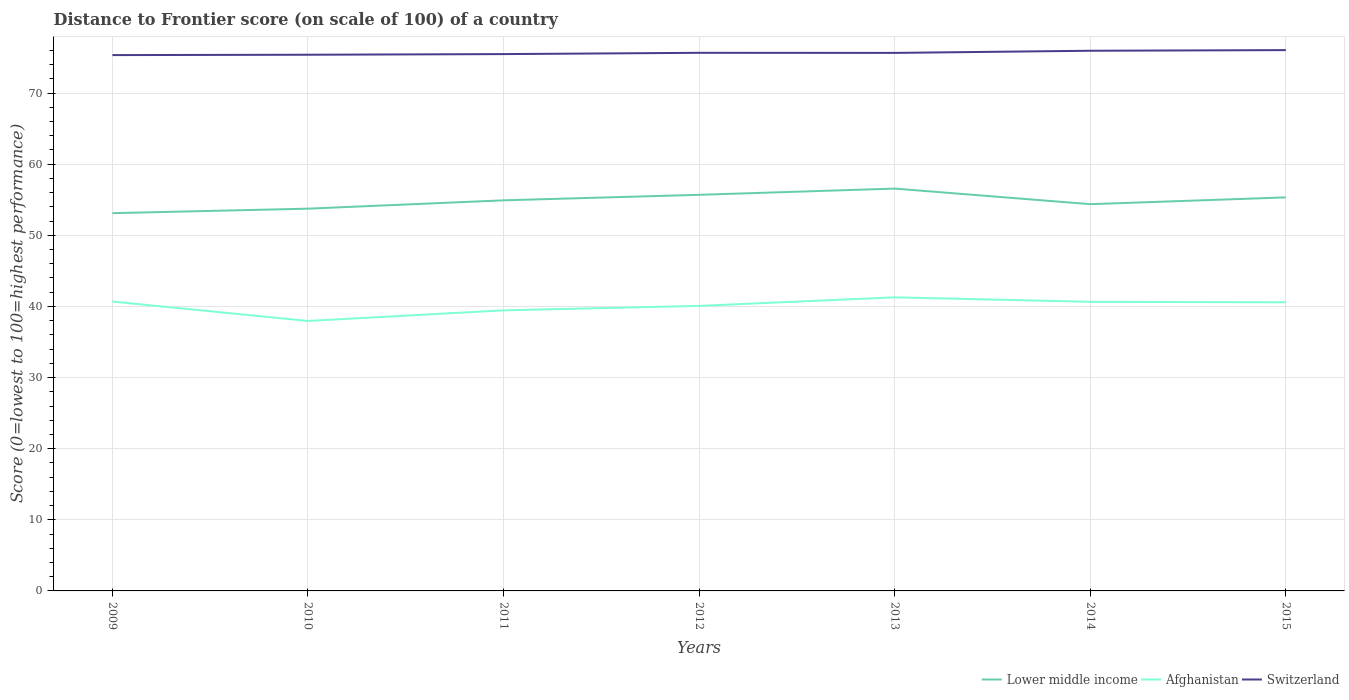Does the line corresponding to Switzerland intersect with the line corresponding to Afghanistan?
Ensure brevity in your answer.  No. Across all years, what is the maximum distance to frontier score of in Switzerland?
Offer a very short reply. 75.34. In which year was the distance to frontier score of in Lower middle income maximum?
Offer a terse response. 2009. What is the total distance to frontier score of in Lower middle income in the graph?
Your response must be concise. -0.87. What is the difference between the highest and the second highest distance to frontier score of in Switzerland?
Your response must be concise. 0.7. What is the difference between the highest and the lowest distance to frontier score of in Switzerland?
Your answer should be compact. 4. How many lines are there?
Ensure brevity in your answer.  3. How many years are there in the graph?
Make the answer very short. 7. What is the difference between two consecutive major ticks on the Y-axis?
Your answer should be very brief. 10. Does the graph contain any zero values?
Your answer should be very brief. No. How are the legend labels stacked?
Offer a terse response. Horizontal. What is the title of the graph?
Your answer should be very brief. Distance to Frontier score (on scale of 100) of a country. What is the label or title of the Y-axis?
Offer a terse response. Score (0=lowest to 100=highest performance). What is the Score (0=lowest to 100=highest performance) of Lower middle income in 2009?
Offer a very short reply. 53.12. What is the Score (0=lowest to 100=highest performance) of Afghanistan in 2009?
Provide a succinct answer. 40.69. What is the Score (0=lowest to 100=highest performance) in Switzerland in 2009?
Your answer should be very brief. 75.34. What is the Score (0=lowest to 100=highest performance) of Lower middle income in 2010?
Your answer should be very brief. 53.75. What is the Score (0=lowest to 100=highest performance) in Afghanistan in 2010?
Make the answer very short. 37.96. What is the Score (0=lowest to 100=highest performance) of Switzerland in 2010?
Provide a short and direct response. 75.39. What is the Score (0=lowest to 100=highest performance) in Lower middle income in 2011?
Keep it short and to the point. 54.92. What is the Score (0=lowest to 100=highest performance) in Afghanistan in 2011?
Offer a very short reply. 39.45. What is the Score (0=lowest to 100=highest performance) in Switzerland in 2011?
Ensure brevity in your answer.  75.48. What is the Score (0=lowest to 100=highest performance) in Lower middle income in 2012?
Your response must be concise. 55.7. What is the Score (0=lowest to 100=highest performance) in Afghanistan in 2012?
Your answer should be very brief. 40.08. What is the Score (0=lowest to 100=highest performance) of Switzerland in 2012?
Offer a terse response. 75.66. What is the Score (0=lowest to 100=highest performance) of Lower middle income in 2013?
Keep it short and to the point. 56.57. What is the Score (0=lowest to 100=highest performance) of Afghanistan in 2013?
Provide a short and direct response. 41.28. What is the Score (0=lowest to 100=highest performance) of Switzerland in 2013?
Your answer should be very brief. 75.65. What is the Score (0=lowest to 100=highest performance) in Lower middle income in 2014?
Your answer should be very brief. 54.38. What is the Score (0=lowest to 100=highest performance) in Afghanistan in 2014?
Make the answer very short. 40.65. What is the Score (0=lowest to 100=highest performance) of Switzerland in 2014?
Keep it short and to the point. 75.95. What is the Score (0=lowest to 100=highest performance) of Lower middle income in 2015?
Ensure brevity in your answer.  55.33. What is the Score (0=lowest to 100=highest performance) in Afghanistan in 2015?
Your response must be concise. 40.58. What is the Score (0=lowest to 100=highest performance) of Switzerland in 2015?
Your answer should be compact. 76.04. Across all years, what is the maximum Score (0=lowest to 100=highest performance) in Lower middle income?
Your answer should be compact. 56.57. Across all years, what is the maximum Score (0=lowest to 100=highest performance) of Afghanistan?
Keep it short and to the point. 41.28. Across all years, what is the maximum Score (0=lowest to 100=highest performance) in Switzerland?
Ensure brevity in your answer.  76.04. Across all years, what is the minimum Score (0=lowest to 100=highest performance) in Lower middle income?
Your answer should be compact. 53.12. Across all years, what is the minimum Score (0=lowest to 100=highest performance) in Afghanistan?
Make the answer very short. 37.96. Across all years, what is the minimum Score (0=lowest to 100=highest performance) of Switzerland?
Your response must be concise. 75.34. What is the total Score (0=lowest to 100=highest performance) in Lower middle income in the graph?
Give a very brief answer. 383.76. What is the total Score (0=lowest to 100=highest performance) of Afghanistan in the graph?
Give a very brief answer. 280.69. What is the total Score (0=lowest to 100=highest performance) of Switzerland in the graph?
Your answer should be very brief. 529.51. What is the difference between the Score (0=lowest to 100=highest performance) in Lower middle income in 2009 and that in 2010?
Ensure brevity in your answer.  -0.63. What is the difference between the Score (0=lowest to 100=highest performance) in Afghanistan in 2009 and that in 2010?
Your answer should be very brief. 2.73. What is the difference between the Score (0=lowest to 100=highest performance) of Lower middle income in 2009 and that in 2011?
Your response must be concise. -1.8. What is the difference between the Score (0=lowest to 100=highest performance) of Afghanistan in 2009 and that in 2011?
Give a very brief answer. 1.24. What is the difference between the Score (0=lowest to 100=highest performance) in Switzerland in 2009 and that in 2011?
Provide a succinct answer. -0.14. What is the difference between the Score (0=lowest to 100=highest performance) of Lower middle income in 2009 and that in 2012?
Your answer should be compact. -2.58. What is the difference between the Score (0=lowest to 100=highest performance) in Afghanistan in 2009 and that in 2012?
Ensure brevity in your answer.  0.61. What is the difference between the Score (0=lowest to 100=highest performance) of Switzerland in 2009 and that in 2012?
Your answer should be compact. -0.32. What is the difference between the Score (0=lowest to 100=highest performance) of Lower middle income in 2009 and that in 2013?
Your response must be concise. -3.45. What is the difference between the Score (0=lowest to 100=highest performance) in Afghanistan in 2009 and that in 2013?
Keep it short and to the point. -0.59. What is the difference between the Score (0=lowest to 100=highest performance) of Switzerland in 2009 and that in 2013?
Ensure brevity in your answer.  -0.31. What is the difference between the Score (0=lowest to 100=highest performance) in Lower middle income in 2009 and that in 2014?
Provide a succinct answer. -1.26. What is the difference between the Score (0=lowest to 100=highest performance) in Afghanistan in 2009 and that in 2014?
Offer a terse response. 0.04. What is the difference between the Score (0=lowest to 100=highest performance) of Switzerland in 2009 and that in 2014?
Give a very brief answer. -0.61. What is the difference between the Score (0=lowest to 100=highest performance) in Lower middle income in 2009 and that in 2015?
Ensure brevity in your answer.  -2.22. What is the difference between the Score (0=lowest to 100=highest performance) of Afghanistan in 2009 and that in 2015?
Give a very brief answer. 0.11. What is the difference between the Score (0=lowest to 100=highest performance) in Switzerland in 2009 and that in 2015?
Ensure brevity in your answer.  -0.7. What is the difference between the Score (0=lowest to 100=highest performance) of Lower middle income in 2010 and that in 2011?
Keep it short and to the point. -1.17. What is the difference between the Score (0=lowest to 100=highest performance) in Afghanistan in 2010 and that in 2011?
Provide a short and direct response. -1.49. What is the difference between the Score (0=lowest to 100=highest performance) in Switzerland in 2010 and that in 2011?
Ensure brevity in your answer.  -0.09. What is the difference between the Score (0=lowest to 100=highest performance) of Lower middle income in 2010 and that in 2012?
Ensure brevity in your answer.  -1.95. What is the difference between the Score (0=lowest to 100=highest performance) in Afghanistan in 2010 and that in 2012?
Keep it short and to the point. -2.12. What is the difference between the Score (0=lowest to 100=highest performance) of Switzerland in 2010 and that in 2012?
Make the answer very short. -0.27. What is the difference between the Score (0=lowest to 100=highest performance) of Lower middle income in 2010 and that in 2013?
Provide a succinct answer. -2.83. What is the difference between the Score (0=lowest to 100=highest performance) of Afghanistan in 2010 and that in 2013?
Provide a succinct answer. -3.32. What is the difference between the Score (0=lowest to 100=highest performance) in Switzerland in 2010 and that in 2013?
Make the answer very short. -0.26. What is the difference between the Score (0=lowest to 100=highest performance) of Lower middle income in 2010 and that in 2014?
Give a very brief answer. -0.63. What is the difference between the Score (0=lowest to 100=highest performance) of Afghanistan in 2010 and that in 2014?
Give a very brief answer. -2.69. What is the difference between the Score (0=lowest to 100=highest performance) in Switzerland in 2010 and that in 2014?
Your answer should be compact. -0.56. What is the difference between the Score (0=lowest to 100=highest performance) of Lower middle income in 2010 and that in 2015?
Provide a short and direct response. -1.59. What is the difference between the Score (0=lowest to 100=highest performance) in Afghanistan in 2010 and that in 2015?
Make the answer very short. -2.62. What is the difference between the Score (0=lowest to 100=highest performance) in Switzerland in 2010 and that in 2015?
Make the answer very short. -0.65. What is the difference between the Score (0=lowest to 100=highest performance) of Lower middle income in 2011 and that in 2012?
Keep it short and to the point. -0.78. What is the difference between the Score (0=lowest to 100=highest performance) of Afghanistan in 2011 and that in 2012?
Offer a terse response. -0.63. What is the difference between the Score (0=lowest to 100=highest performance) in Switzerland in 2011 and that in 2012?
Ensure brevity in your answer.  -0.18. What is the difference between the Score (0=lowest to 100=highest performance) of Lower middle income in 2011 and that in 2013?
Offer a terse response. -1.65. What is the difference between the Score (0=lowest to 100=highest performance) in Afghanistan in 2011 and that in 2013?
Offer a very short reply. -1.83. What is the difference between the Score (0=lowest to 100=highest performance) of Switzerland in 2011 and that in 2013?
Keep it short and to the point. -0.17. What is the difference between the Score (0=lowest to 100=highest performance) of Lower middle income in 2011 and that in 2014?
Ensure brevity in your answer.  0.54. What is the difference between the Score (0=lowest to 100=highest performance) in Switzerland in 2011 and that in 2014?
Provide a short and direct response. -0.47. What is the difference between the Score (0=lowest to 100=highest performance) in Lower middle income in 2011 and that in 2015?
Offer a terse response. -0.41. What is the difference between the Score (0=lowest to 100=highest performance) in Afghanistan in 2011 and that in 2015?
Your response must be concise. -1.13. What is the difference between the Score (0=lowest to 100=highest performance) in Switzerland in 2011 and that in 2015?
Your response must be concise. -0.56. What is the difference between the Score (0=lowest to 100=highest performance) of Lower middle income in 2012 and that in 2013?
Give a very brief answer. -0.88. What is the difference between the Score (0=lowest to 100=highest performance) of Afghanistan in 2012 and that in 2013?
Offer a terse response. -1.2. What is the difference between the Score (0=lowest to 100=highest performance) of Lower middle income in 2012 and that in 2014?
Give a very brief answer. 1.32. What is the difference between the Score (0=lowest to 100=highest performance) of Afghanistan in 2012 and that in 2014?
Provide a succinct answer. -0.57. What is the difference between the Score (0=lowest to 100=highest performance) of Switzerland in 2012 and that in 2014?
Ensure brevity in your answer.  -0.29. What is the difference between the Score (0=lowest to 100=highest performance) in Lower middle income in 2012 and that in 2015?
Offer a very short reply. 0.36. What is the difference between the Score (0=lowest to 100=highest performance) of Afghanistan in 2012 and that in 2015?
Provide a short and direct response. -0.5. What is the difference between the Score (0=lowest to 100=highest performance) of Switzerland in 2012 and that in 2015?
Ensure brevity in your answer.  -0.38. What is the difference between the Score (0=lowest to 100=highest performance) in Lower middle income in 2013 and that in 2014?
Keep it short and to the point. 2.19. What is the difference between the Score (0=lowest to 100=highest performance) of Afghanistan in 2013 and that in 2014?
Offer a very short reply. 0.63. What is the difference between the Score (0=lowest to 100=highest performance) of Lower middle income in 2013 and that in 2015?
Your response must be concise. 1.24. What is the difference between the Score (0=lowest to 100=highest performance) of Afghanistan in 2013 and that in 2015?
Provide a short and direct response. 0.7. What is the difference between the Score (0=lowest to 100=highest performance) in Switzerland in 2013 and that in 2015?
Your answer should be compact. -0.39. What is the difference between the Score (0=lowest to 100=highest performance) in Lower middle income in 2014 and that in 2015?
Ensure brevity in your answer.  -0.95. What is the difference between the Score (0=lowest to 100=highest performance) in Afghanistan in 2014 and that in 2015?
Offer a very short reply. 0.07. What is the difference between the Score (0=lowest to 100=highest performance) of Switzerland in 2014 and that in 2015?
Your response must be concise. -0.09. What is the difference between the Score (0=lowest to 100=highest performance) of Lower middle income in 2009 and the Score (0=lowest to 100=highest performance) of Afghanistan in 2010?
Your answer should be compact. 15.16. What is the difference between the Score (0=lowest to 100=highest performance) of Lower middle income in 2009 and the Score (0=lowest to 100=highest performance) of Switzerland in 2010?
Provide a short and direct response. -22.27. What is the difference between the Score (0=lowest to 100=highest performance) in Afghanistan in 2009 and the Score (0=lowest to 100=highest performance) in Switzerland in 2010?
Your response must be concise. -34.7. What is the difference between the Score (0=lowest to 100=highest performance) in Lower middle income in 2009 and the Score (0=lowest to 100=highest performance) in Afghanistan in 2011?
Offer a very short reply. 13.67. What is the difference between the Score (0=lowest to 100=highest performance) in Lower middle income in 2009 and the Score (0=lowest to 100=highest performance) in Switzerland in 2011?
Make the answer very short. -22.36. What is the difference between the Score (0=lowest to 100=highest performance) in Afghanistan in 2009 and the Score (0=lowest to 100=highest performance) in Switzerland in 2011?
Provide a short and direct response. -34.79. What is the difference between the Score (0=lowest to 100=highest performance) of Lower middle income in 2009 and the Score (0=lowest to 100=highest performance) of Afghanistan in 2012?
Offer a very short reply. 13.04. What is the difference between the Score (0=lowest to 100=highest performance) in Lower middle income in 2009 and the Score (0=lowest to 100=highest performance) in Switzerland in 2012?
Ensure brevity in your answer.  -22.54. What is the difference between the Score (0=lowest to 100=highest performance) of Afghanistan in 2009 and the Score (0=lowest to 100=highest performance) of Switzerland in 2012?
Provide a succinct answer. -34.97. What is the difference between the Score (0=lowest to 100=highest performance) of Lower middle income in 2009 and the Score (0=lowest to 100=highest performance) of Afghanistan in 2013?
Give a very brief answer. 11.84. What is the difference between the Score (0=lowest to 100=highest performance) in Lower middle income in 2009 and the Score (0=lowest to 100=highest performance) in Switzerland in 2013?
Make the answer very short. -22.53. What is the difference between the Score (0=lowest to 100=highest performance) of Afghanistan in 2009 and the Score (0=lowest to 100=highest performance) of Switzerland in 2013?
Provide a short and direct response. -34.96. What is the difference between the Score (0=lowest to 100=highest performance) in Lower middle income in 2009 and the Score (0=lowest to 100=highest performance) in Afghanistan in 2014?
Your answer should be very brief. 12.47. What is the difference between the Score (0=lowest to 100=highest performance) in Lower middle income in 2009 and the Score (0=lowest to 100=highest performance) in Switzerland in 2014?
Keep it short and to the point. -22.83. What is the difference between the Score (0=lowest to 100=highest performance) of Afghanistan in 2009 and the Score (0=lowest to 100=highest performance) of Switzerland in 2014?
Give a very brief answer. -35.26. What is the difference between the Score (0=lowest to 100=highest performance) in Lower middle income in 2009 and the Score (0=lowest to 100=highest performance) in Afghanistan in 2015?
Ensure brevity in your answer.  12.54. What is the difference between the Score (0=lowest to 100=highest performance) of Lower middle income in 2009 and the Score (0=lowest to 100=highest performance) of Switzerland in 2015?
Provide a succinct answer. -22.92. What is the difference between the Score (0=lowest to 100=highest performance) of Afghanistan in 2009 and the Score (0=lowest to 100=highest performance) of Switzerland in 2015?
Your answer should be very brief. -35.35. What is the difference between the Score (0=lowest to 100=highest performance) of Lower middle income in 2010 and the Score (0=lowest to 100=highest performance) of Afghanistan in 2011?
Make the answer very short. 14.3. What is the difference between the Score (0=lowest to 100=highest performance) in Lower middle income in 2010 and the Score (0=lowest to 100=highest performance) in Switzerland in 2011?
Provide a short and direct response. -21.73. What is the difference between the Score (0=lowest to 100=highest performance) in Afghanistan in 2010 and the Score (0=lowest to 100=highest performance) in Switzerland in 2011?
Offer a terse response. -37.52. What is the difference between the Score (0=lowest to 100=highest performance) of Lower middle income in 2010 and the Score (0=lowest to 100=highest performance) of Afghanistan in 2012?
Keep it short and to the point. 13.67. What is the difference between the Score (0=lowest to 100=highest performance) in Lower middle income in 2010 and the Score (0=lowest to 100=highest performance) in Switzerland in 2012?
Your response must be concise. -21.91. What is the difference between the Score (0=lowest to 100=highest performance) of Afghanistan in 2010 and the Score (0=lowest to 100=highest performance) of Switzerland in 2012?
Keep it short and to the point. -37.7. What is the difference between the Score (0=lowest to 100=highest performance) of Lower middle income in 2010 and the Score (0=lowest to 100=highest performance) of Afghanistan in 2013?
Make the answer very short. 12.47. What is the difference between the Score (0=lowest to 100=highest performance) of Lower middle income in 2010 and the Score (0=lowest to 100=highest performance) of Switzerland in 2013?
Make the answer very short. -21.9. What is the difference between the Score (0=lowest to 100=highest performance) in Afghanistan in 2010 and the Score (0=lowest to 100=highest performance) in Switzerland in 2013?
Give a very brief answer. -37.69. What is the difference between the Score (0=lowest to 100=highest performance) in Lower middle income in 2010 and the Score (0=lowest to 100=highest performance) in Afghanistan in 2014?
Keep it short and to the point. 13.1. What is the difference between the Score (0=lowest to 100=highest performance) in Lower middle income in 2010 and the Score (0=lowest to 100=highest performance) in Switzerland in 2014?
Provide a succinct answer. -22.2. What is the difference between the Score (0=lowest to 100=highest performance) in Afghanistan in 2010 and the Score (0=lowest to 100=highest performance) in Switzerland in 2014?
Your answer should be very brief. -37.99. What is the difference between the Score (0=lowest to 100=highest performance) of Lower middle income in 2010 and the Score (0=lowest to 100=highest performance) of Afghanistan in 2015?
Keep it short and to the point. 13.17. What is the difference between the Score (0=lowest to 100=highest performance) in Lower middle income in 2010 and the Score (0=lowest to 100=highest performance) in Switzerland in 2015?
Give a very brief answer. -22.29. What is the difference between the Score (0=lowest to 100=highest performance) in Afghanistan in 2010 and the Score (0=lowest to 100=highest performance) in Switzerland in 2015?
Make the answer very short. -38.08. What is the difference between the Score (0=lowest to 100=highest performance) in Lower middle income in 2011 and the Score (0=lowest to 100=highest performance) in Afghanistan in 2012?
Keep it short and to the point. 14.84. What is the difference between the Score (0=lowest to 100=highest performance) in Lower middle income in 2011 and the Score (0=lowest to 100=highest performance) in Switzerland in 2012?
Make the answer very short. -20.74. What is the difference between the Score (0=lowest to 100=highest performance) of Afghanistan in 2011 and the Score (0=lowest to 100=highest performance) of Switzerland in 2012?
Give a very brief answer. -36.21. What is the difference between the Score (0=lowest to 100=highest performance) in Lower middle income in 2011 and the Score (0=lowest to 100=highest performance) in Afghanistan in 2013?
Give a very brief answer. 13.64. What is the difference between the Score (0=lowest to 100=highest performance) in Lower middle income in 2011 and the Score (0=lowest to 100=highest performance) in Switzerland in 2013?
Make the answer very short. -20.73. What is the difference between the Score (0=lowest to 100=highest performance) in Afghanistan in 2011 and the Score (0=lowest to 100=highest performance) in Switzerland in 2013?
Offer a very short reply. -36.2. What is the difference between the Score (0=lowest to 100=highest performance) in Lower middle income in 2011 and the Score (0=lowest to 100=highest performance) in Afghanistan in 2014?
Make the answer very short. 14.27. What is the difference between the Score (0=lowest to 100=highest performance) in Lower middle income in 2011 and the Score (0=lowest to 100=highest performance) in Switzerland in 2014?
Your response must be concise. -21.03. What is the difference between the Score (0=lowest to 100=highest performance) in Afghanistan in 2011 and the Score (0=lowest to 100=highest performance) in Switzerland in 2014?
Your response must be concise. -36.5. What is the difference between the Score (0=lowest to 100=highest performance) in Lower middle income in 2011 and the Score (0=lowest to 100=highest performance) in Afghanistan in 2015?
Your response must be concise. 14.34. What is the difference between the Score (0=lowest to 100=highest performance) in Lower middle income in 2011 and the Score (0=lowest to 100=highest performance) in Switzerland in 2015?
Ensure brevity in your answer.  -21.12. What is the difference between the Score (0=lowest to 100=highest performance) of Afghanistan in 2011 and the Score (0=lowest to 100=highest performance) of Switzerland in 2015?
Make the answer very short. -36.59. What is the difference between the Score (0=lowest to 100=highest performance) of Lower middle income in 2012 and the Score (0=lowest to 100=highest performance) of Afghanistan in 2013?
Make the answer very short. 14.42. What is the difference between the Score (0=lowest to 100=highest performance) of Lower middle income in 2012 and the Score (0=lowest to 100=highest performance) of Switzerland in 2013?
Provide a short and direct response. -19.95. What is the difference between the Score (0=lowest to 100=highest performance) of Afghanistan in 2012 and the Score (0=lowest to 100=highest performance) of Switzerland in 2013?
Provide a succinct answer. -35.57. What is the difference between the Score (0=lowest to 100=highest performance) of Lower middle income in 2012 and the Score (0=lowest to 100=highest performance) of Afghanistan in 2014?
Your answer should be very brief. 15.05. What is the difference between the Score (0=lowest to 100=highest performance) in Lower middle income in 2012 and the Score (0=lowest to 100=highest performance) in Switzerland in 2014?
Offer a terse response. -20.25. What is the difference between the Score (0=lowest to 100=highest performance) in Afghanistan in 2012 and the Score (0=lowest to 100=highest performance) in Switzerland in 2014?
Provide a short and direct response. -35.87. What is the difference between the Score (0=lowest to 100=highest performance) of Lower middle income in 2012 and the Score (0=lowest to 100=highest performance) of Afghanistan in 2015?
Offer a very short reply. 15.12. What is the difference between the Score (0=lowest to 100=highest performance) in Lower middle income in 2012 and the Score (0=lowest to 100=highest performance) in Switzerland in 2015?
Offer a terse response. -20.34. What is the difference between the Score (0=lowest to 100=highest performance) in Afghanistan in 2012 and the Score (0=lowest to 100=highest performance) in Switzerland in 2015?
Give a very brief answer. -35.96. What is the difference between the Score (0=lowest to 100=highest performance) of Lower middle income in 2013 and the Score (0=lowest to 100=highest performance) of Afghanistan in 2014?
Give a very brief answer. 15.92. What is the difference between the Score (0=lowest to 100=highest performance) in Lower middle income in 2013 and the Score (0=lowest to 100=highest performance) in Switzerland in 2014?
Make the answer very short. -19.38. What is the difference between the Score (0=lowest to 100=highest performance) of Afghanistan in 2013 and the Score (0=lowest to 100=highest performance) of Switzerland in 2014?
Offer a terse response. -34.67. What is the difference between the Score (0=lowest to 100=highest performance) of Lower middle income in 2013 and the Score (0=lowest to 100=highest performance) of Afghanistan in 2015?
Make the answer very short. 15.99. What is the difference between the Score (0=lowest to 100=highest performance) in Lower middle income in 2013 and the Score (0=lowest to 100=highest performance) in Switzerland in 2015?
Keep it short and to the point. -19.47. What is the difference between the Score (0=lowest to 100=highest performance) of Afghanistan in 2013 and the Score (0=lowest to 100=highest performance) of Switzerland in 2015?
Your answer should be very brief. -34.76. What is the difference between the Score (0=lowest to 100=highest performance) of Lower middle income in 2014 and the Score (0=lowest to 100=highest performance) of Afghanistan in 2015?
Offer a terse response. 13.8. What is the difference between the Score (0=lowest to 100=highest performance) in Lower middle income in 2014 and the Score (0=lowest to 100=highest performance) in Switzerland in 2015?
Keep it short and to the point. -21.66. What is the difference between the Score (0=lowest to 100=highest performance) in Afghanistan in 2014 and the Score (0=lowest to 100=highest performance) in Switzerland in 2015?
Keep it short and to the point. -35.39. What is the average Score (0=lowest to 100=highest performance) of Lower middle income per year?
Give a very brief answer. 54.82. What is the average Score (0=lowest to 100=highest performance) in Afghanistan per year?
Make the answer very short. 40.1. What is the average Score (0=lowest to 100=highest performance) in Switzerland per year?
Offer a terse response. 75.64. In the year 2009, what is the difference between the Score (0=lowest to 100=highest performance) in Lower middle income and Score (0=lowest to 100=highest performance) in Afghanistan?
Your answer should be compact. 12.43. In the year 2009, what is the difference between the Score (0=lowest to 100=highest performance) of Lower middle income and Score (0=lowest to 100=highest performance) of Switzerland?
Keep it short and to the point. -22.22. In the year 2009, what is the difference between the Score (0=lowest to 100=highest performance) of Afghanistan and Score (0=lowest to 100=highest performance) of Switzerland?
Offer a terse response. -34.65. In the year 2010, what is the difference between the Score (0=lowest to 100=highest performance) in Lower middle income and Score (0=lowest to 100=highest performance) in Afghanistan?
Give a very brief answer. 15.79. In the year 2010, what is the difference between the Score (0=lowest to 100=highest performance) in Lower middle income and Score (0=lowest to 100=highest performance) in Switzerland?
Give a very brief answer. -21.64. In the year 2010, what is the difference between the Score (0=lowest to 100=highest performance) of Afghanistan and Score (0=lowest to 100=highest performance) of Switzerland?
Ensure brevity in your answer.  -37.43. In the year 2011, what is the difference between the Score (0=lowest to 100=highest performance) in Lower middle income and Score (0=lowest to 100=highest performance) in Afghanistan?
Offer a very short reply. 15.47. In the year 2011, what is the difference between the Score (0=lowest to 100=highest performance) of Lower middle income and Score (0=lowest to 100=highest performance) of Switzerland?
Make the answer very short. -20.56. In the year 2011, what is the difference between the Score (0=lowest to 100=highest performance) in Afghanistan and Score (0=lowest to 100=highest performance) in Switzerland?
Your response must be concise. -36.03. In the year 2012, what is the difference between the Score (0=lowest to 100=highest performance) of Lower middle income and Score (0=lowest to 100=highest performance) of Afghanistan?
Your answer should be compact. 15.62. In the year 2012, what is the difference between the Score (0=lowest to 100=highest performance) in Lower middle income and Score (0=lowest to 100=highest performance) in Switzerland?
Give a very brief answer. -19.96. In the year 2012, what is the difference between the Score (0=lowest to 100=highest performance) in Afghanistan and Score (0=lowest to 100=highest performance) in Switzerland?
Provide a short and direct response. -35.58. In the year 2013, what is the difference between the Score (0=lowest to 100=highest performance) of Lower middle income and Score (0=lowest to 100=highest performance) of Afghanistan?
Your answer should be very brief. 15.29. In the year 2013, what is the difference between the Score (0=lowest to 100=highest performance) of Lower middle income and Score (0=lowest to 100=highest performance) of Switzerland?
Give a very brief answer. -19.08. In the year 2013, what is the difference between the Score (0=lowest to 100=highest performance) of Afghanistan and Score (0=lowest to 100=highest performance) of Switzerland?
Offer a very short reply. -34.37. In the year 2014, what is the difference between the Score (0=lowest to 100=highest performance) of Lower middle income and Score (0=lowest to 100=highest performance) of Afghanistan?
Your answer should be compact. 13.73. In the year 2014, what is the difference between the Score (0=lowest to 100=highest performance) of Lower middle income and Score (0=lowest to 100=highest performance) of Switzerland?
Provide a succinct answer. -21.57. In the year 2014, what is the difference between the Score (0=lowest to 100=highest performance) of Afghanistan and Score (0=lowest to 100=highest performance) of Switzerland?
Offer a very short reply. -35.3. In the year 2015, what is the difference between the Score (0=lowest to 100=highest performance) in Lower middle income and Score (0=lowest to 100=highest performance) in Afghanistan?
Provide a short and direct response. 14.75. In the year 2015, what is the difference between the Score (0=lowest to 100=highest performance) in Lower middle income and Score (0=lowest to 100=highest performance) in Switzerland?
Provide a succinct answer. -20.71. In the year 2015, what is the difference between the Score (0=lowest to 100=highest performance) of Afghanistan and Score (0=lowest to 100=highest performance) of Switzerland?
Keep it short and to the point. -35.46. What is the ratio of the Score (0=lowest to 100=highest performance) in Lower middle income in 2009 to that in 2010?
Your response must be concise. 0.99. What is the ratio of the Score (0=lowest to 100=highest performance) in Afghanistan in 2009 to that in 2010?
Provide a succinct answer. 1.07. What is the ratio of the Score (0=lowest to 100=highest performance) in Switzerland in 2009 to that in 2010?
Provide a short and direct response. 1. What is the ratio of the Score (0=lowest to 100=highest performance) in Lower middle income in 2009 to that in 2011?
Ensure brevity in your answer.  0.97. What is the ratio of the Score (0=lowest to 100=highest performance) of Afghanistan in 2009 to that in 2011?
Your answer should be compact. 1.03. What is the ratio of the Score (0=lowest to 100=highest performance) in Lower middle income in 2009 to that in 2012?
Provide a succinct answer. 0.95. What is the ratio of the Score (0=lowest to 100=highest performance) of Afghanistan in 2009 to that in 2012?
Offer a very short reply. 1.02. What is the ratio of the Score (0=lowest to 100=highest performance) of Switzerland in 2009 to that in 2012?
Your response must be concise. 1. What is the ratio of the Score (0=lowest to 100=highest performance) in Lower middle income in 2009 to that in 2013?
Offer a very short reply. 0.94. What is the ratio of the Score (0=lowest to 100=highest performance) in Afghanistan in 2009 to that in 2013?
Your response must be concise. 0.99. What is the ratio of the Score (0=lowest to 100=highest performance) in Lower middle income in 2009 to that in 2014?
Your response must be concise. 0.98. What is the ratio of the Score (0=lowest to 100=highest performance) in Afghanistan in 2009 to that in 2014?
Your answer should be compact. 1. What is the ratio of the Score (0=lowest to 100=highest performance) of Switzerland in 2009 to that in 2014?
Keep it short and to the point. 0.99. What is the ratio of the Score (0=lowest to 100=highest performance) of Lower middle income in 2009 to that in 2015?
Your response must be concise. 0.96. What is the ratio of the Score (0=lowest to 100=highest performance) of Switzerland in 2009 to that in 2015?
Give a very brief answer. 0.99. What is the ratio of the Score (0=lowest to 100=highest performance) of Lower middle income in 2010 to that in 2011?
Your response must be concise. 0.98. What is the ratio of the Score (0=lowest to 100=highest performance) in Afghanistan in 2010 to that in 2011?
Offer a very short reply. 0.96. What is the ratio of the Score (0=lowest to 100=highest performance) of Switzerland in 2010 to that in 2011?
Ensure brevity in your answer.  1. What is the ratio of the Score (0=lowest to 100=highest performance) in Afghanistan in 2010 to that in 2012?
Your answer should be very brief. 0.95. What is the ratio of the Score (0=lowest to 100=highest performance) of Switzerland in 2010 to that in 2012?
Offer a very short reply. 1. What is the ratio of the Score (0=lowest to 100=highest performance) of Lower middle income in 2010 to that in 2013?
Ensure brevity in your answer.  0.95. What is the ratio of the Score (0=lowest to 100=highest performance) of Afghanistan in 2010 to that in 2013?
Offer a terse response. 0.92. What is the ratio of the Score (0=lowest to 100=highest performance) of Switzerland in 2010 to that in 2013?
Ensure brevity in your answer.  1. What is the ratio of the Score (0=lowest to 100=highest performance) of Lower middle income in 2010 to that in 2014?
Make the answer very short. 0.99. What is the ratio of the Score (0=lowest to 100=highest performance) in Afghanistan in 2010 to that in 2014?
Give a very brief answer. 0.93. What is the ratio of the Score (0=lowest to 100=highest performance) of Switzerland in 2010 to that in 2014?
Provide a succinct answer. 0.99. What is the ratio of the Score (0=lowest to 100=highest performance) of Lower middle income in 2010 to that in 2015?
Give a very brief answer. 0.97. What is the ratio of the Score (0=lowest to 100=highest performance) in Afghanistan in 2010 to that in 2015?
Provide a short and direct response. 0.94. What is the ratio of the Score (0=lowest to 100=highest performance) of Switzerland in 2010 to that in 2015?
Provide a succinct answer. 0.99. What is the ratio of the Score (0=lowest to 100=highest performance) of Lower middle income in 2011 to that in 2012?
Offer a very short reply. 0.99. What is the ratio of the Score (0=lowest to 100=highest performance) of Afghanistan in 2011 to that in 2012?
Provide a short and direct response. 0.98. What is the ratio of the Score (0=lowest to 100=highest performance) of Lower middle income in 2011 to that in 2013?
Your answer should be very brief. 0.97. What is the ratio of the Score (0=lowest to 100=highest performance) in Afghanistan in 2011 to that in 2013?
Make the answer very short. 0.96. What is the ratio of the Score (0=lowest to 100=highest performance) in Switzerland in 2011 to that in 2013?
Your answer should be compact. 1. What is the ratio of the Score (0=lowest to 100=highest performance) in Lower middle income in 2011 to that in 2014?
Provide a short and direct response. 1.01. What is the ratio of the Score (0=lowest to 100=highest performance) of Afghanistan in 2011 to that in 2014?
Provide a short and direct response. 0.97. What is the ratio of the Score (0=lowest to 100=highest performance) in Afghanistan in 2011 to that in 2015?
Make the answer very short. 0.97. What is the ratio of the Score (0=lowest to 100=highest performance) of Switzerland in 2011 to that in 2015?
Offer a terse response. 0.99. What is the ratio of the Score (0=lowest to 100=highest performance) in Lower middle income in 2012 to that in 2013?
Keep it short and to the point. 0.98. What is the ratio of the Score (0=lowest to 100=highest performance) in Afghanistan in 2012 to that in 2013?
Offer a terse response. 0.97. What is the ratio of the Score (0=lowest to 100=highest performance) of Switzerland in 2012 to that in 2013?
Offer a terse response. 1. What is the ratio of the Score (0=lowest to 100=highest performance) of Lower middle income in 2012 to that in 2014?
Your answer should be compact. 1.02. What is the ratio of the Score (0=lowest to 100=highest performance) in Afghanistan in 2012 to that in 2014?
Offer a very short reply. 0.99. What is the ratio of the Score (0=lowest to 100=highest performance) of Lower middle income in 2012 to that in 2015?
Keep it short and to the point. 1.01. What is the ratio of the Score (0=lowest to 100=highest performance) in Switzerland in 2012 to that in 2015?
Keep it short and to the point. 0.99. What is the ratio of the Score (0=lowest to 100=highest performance) in Lower middle income in 2013 to that in 2014?
Make the answer very short. 1.04. What is the ratio of the Score (0=lowest to 100=highest performance) of Afghanistan in 2013 to that in 2014?
Your answer should be compact. 1.02. What is the ratio of the Score (0=lowest to 100=highest performance) of Lower middle income in 2013 to that in 2015?
Give a very brief answer. 1.02. What is the ratio of the Score (0=lowest to 100=highest performance) of Afghanistan in 2013 to that in 2015?
Offer a very short reply. 1.02. What is the ratio of the Score (0=lowest to 100=highest performance) of Lower middle income in 2014 to that in 2015?
Your answer should be very brief. 0.98. What is the difference between the highest and the second highest Score (0=lowest to 100=highest performance) in Lower middle income?
Provide a short and direct response. 0.88. What is the difference between the highest and the second highest Score (0=lowest to 100=highest performance) of Afghanistan?
Keep it short and to the point. 0.59. What is the difference between the highest and the second highest Score (0=lowest to 100=highest performance) in Switzerland?
Your answer should be very brief. 0.09. What is the difference between the highest and the lowest Score (0=lowest to 100=highest performance) of Lower middle income?
Provide a short and direct response. 3.45. What is the difference between the highest and the lowest Score (0=lowest to 100=highest performance) in Afghanistan?
Your response must be concise. 3.32. 